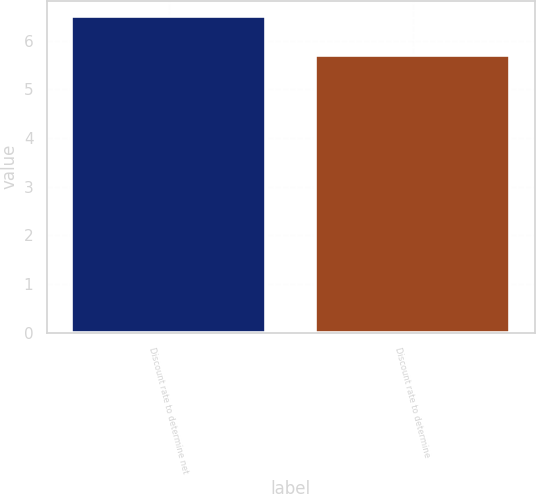<chart> <loc_0><loc_0><loc_500><loc_500><bar_chart><fcel>Discount rate to determine net<fcel>Discount rate to determine<nl><fcel>6.5<fcel>5.71<nl></chart> 